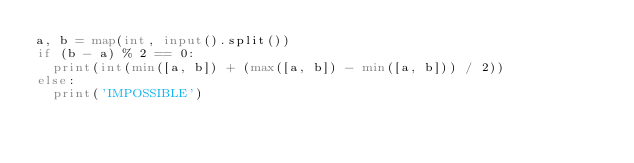<code> <loc_0><loc_0><loc_500><loc_500><_Python_>a, b = map(int, input().split())
if (b - a) % 2 == 0:
  print(int(min([a, b]) + (max([a, b]) - min([a, b])) / 2))
else:
  print('IMPOSSIBLE')</code> 